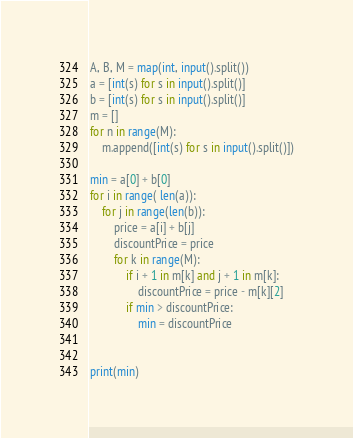<code> <loc_0><loc_0><loc_500><loc_500><_Python_>A, B, M = map(int, input().split())
a = [int(s) for s in input().split()]
b = [int(s) for s in input().split()]
m = []
for n in range(M):
    m.append([int(s) for s in input().split()])

min = a[0] + b[0]
for i in range( len(a)):
    for j in range(len(b)):
        price = a[i] + b[j]
        discountPrice = price
        for k in range(M):
            if i + 1 in m[k] and j + 1 in m[k]:
                discountPrice = price - m[k][2]
            if min > discountPrice:
                min = discountPrice


print(min)
</code> 